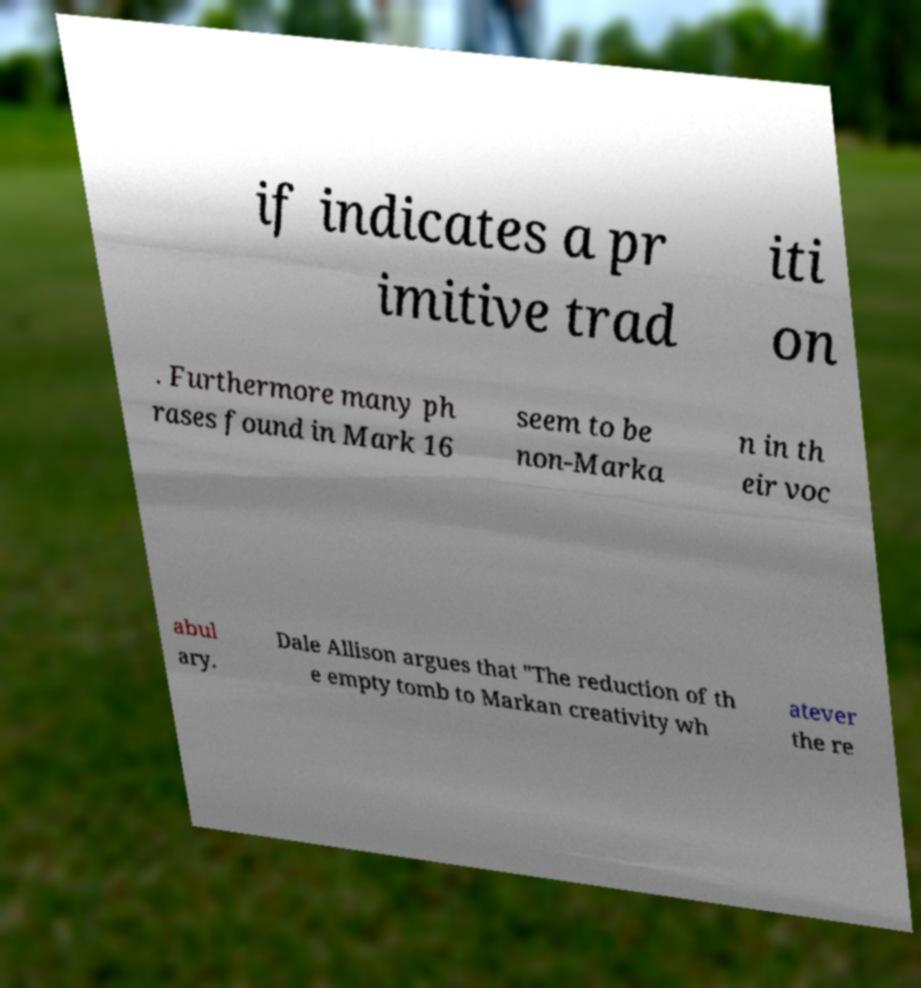Could you assist in decoding the text presented in this image and type it out clearly? if indicates a pr imitive trad iti on . Furthermore many ph rases found in Mark 16 seem to be non-Marka n in th eir voc abul ary. Dale Allison argues that "The reduction of th e empty tomb to Markan creativity wh atever the re 